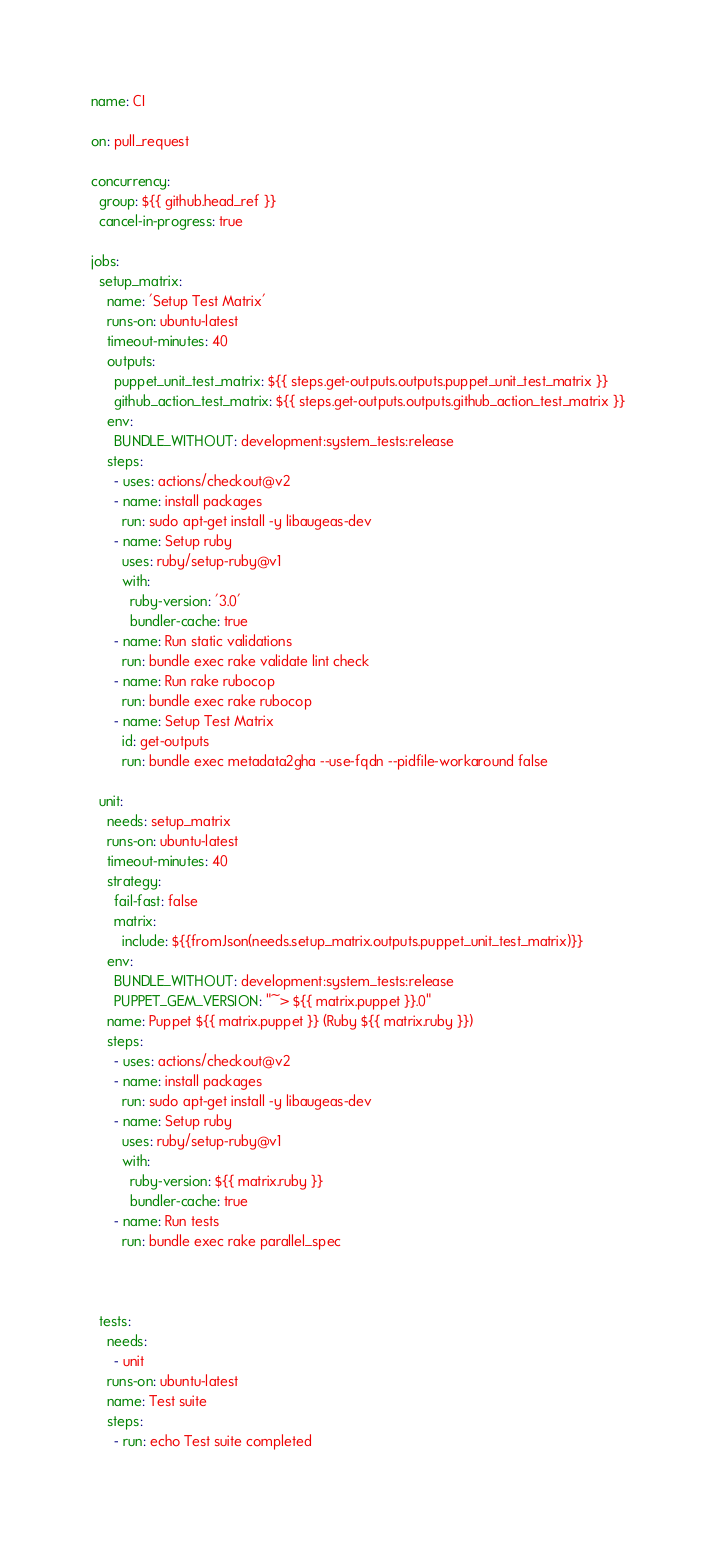Convert code to text. <code><loc_0><loc_0><loc_500><loc_500><_YAML_>
name: CI

on: pull_request

concurrency:
  group: ${{ github.head_ref }}
  cancel-in-progress: true

jobs:
  setup_matrix:
    name: 'Setup Test Matrix'
    runs-on: ubuntu-latest
    timeout-minutes: 40
    outputs:
      puppet_unit_test_matrix: ${{ steps.get-outputs.outputs.puppet_unit_test_matrix }}
      github_action_test_matrix: ${{ steps.get-outputs.outputs.github_action_test_matrix }}
    env:
      BUNDLE_WITHOUT: development:system_tests:release
    steps:
      - uses: actions/checkout@v2
      - name: install packages
        run: sudo apt-get install -y libaugeas-dev
      - name: Setup ruby
        uses: ruby/setup-ruby@v1
        with:
          ruby-version: '3.0'
          bundler-cache: true
      - name: Run static validations
        run: bundle exec rake validate lint check
      - name: Run rake rubocop
        run: bundle exec rake rubocop
      - name: Setup Test Matrix
        id: get-outputs
        run: bundle exec metadata2gha --use-fqdn --pidfile-workaround false

  unit:
    needs: setup_matrix
    runs-on: ubuntu-latest
    timeout-minutes: 40
    strategy:
      fail-fast: false
      matrix:
        include: ${{fromJson(needs.setup_matrix.outputs.puppet_unit_test_matrix)}}
    env:
      BUNDLE_WITHOUT: development:system_tests:release
      PUPPET_GEM_VERSION: "~> ${{ matrix.puppet }}.0"
    name: Puppet ${{ matrix.puppet }} (Ruby ${{ matrix.ruby }})
    steps:
      - uses: actions/checkout@v2
      - name: install packages
        run: sudo apt-get install -y libaugeas-dev
      - name: Setup ruby
        uses: ruby/setup-ruby@v1
        with:
          ruby-version: ${{ matrix.ruby }}
          bundler-cache: true
      - name: Run tests
        run: bundle exec rake parallel_spec



  tests:
    needs:
      - unit
    runs-on: ubuntu-latest
    name: Test suite
    steps:
      - run: echo Test suite completed
</code> 